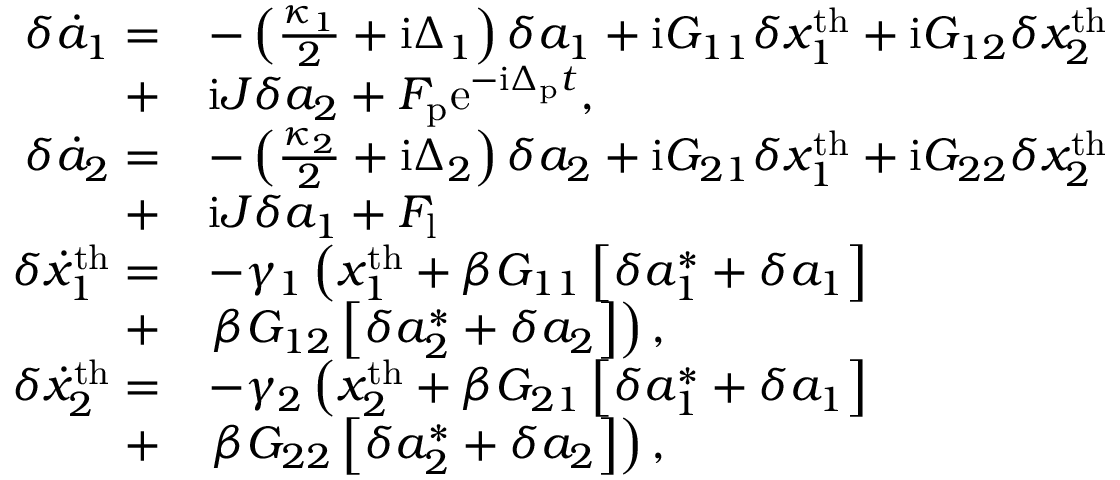Convert formula to latex. <formula><loc_0><loc_0><loc_500><loc_500>\begin{array} { r l } { \delta \dot { a } _ { 1 } = } & { - \left ( \frac { \kappa _ { 1 } } { 2 } + i \Delta _ { 1 } \right ) \delta a _ { 1 } + i G _ { 1 1 } \delta x _ { 1 } ^ { t h } + i G _ { 1 2 } \delta x _ { 2 } ^ { t h } } \\ { + } & { i J \delta a _ { 2 } + F _ { p } e ^ { - i \Delta _ { p } t } , } \\ { \delta \dot { a } _ { 2 } = } & { - \left ( \frac { \kappa _ { 2 } } { 2 } + i \Delta _ { 2 } \right ) \delta a _ { 2 } + i G _ { 2 1 } \delta x _ { 1 } ^ { t h } + i G _ { 2 2 } \delta x _ { 2 } ^ { t h } } \\ { + } & { i J \delta a _ { 1 } + F _ { l } } \\ { \delta \dot { x } _ { 1 } ^ { t h } = } & { - \gamma _ { 1 } \left ( x _ { 1 } ^ { t h } + \beta G _ { 1 1 } \left [ \delta a _ { 1 } ^ { * } + \delta a _ { 1 } \right ] } \\ { + } & { \beta G _ { 1 2 } \left [ \delta a _ { 2 } ^ { * } + \delta a _ { 2 } \right ] \right ) , } \\ { \delta \dot { x } _ { 2 } ^ { t h } = } & { - \gamma _ { 2 } \left ( x _ { 2 } ^ { t h } + \beta G _ { 2 1 } \left [ \delta a _ { 1 } ^ { * } + \delta a _ { 1 } \right ] } \\ { + } & { \beta G _ { 2 2 } \left [ \delta a _ { 2 } ^ { * } + \delta a _ { 2 } \right ] \right ) , } \end{array}</formula> 